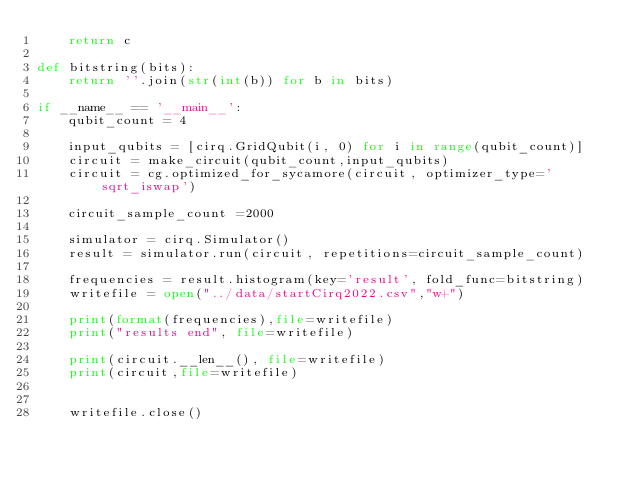Convert code to text. <code><loc_0><loc_0><loc_500><loc_500><_Python_>    return c

def bitstring(bits):
    return ''.join(str(int(b)) for b in bits)

if __name__ == '__main__':
    qubit_count = 4

    input_qubits = [cirq.GridQubit(i, 0) for i in range(qubit_count)]
    circuit = make_circuit(qubit_count,input_qubits)
    circuit = cg.optimized_for_sycamore(circuit, optimizer_type='sqrt_iswap')

    circuit_sample_count =2000

    simulator = cirq.Simulator()
    result = simulator.run(circuit, repetitions=circuit_sample_count)

    frequencies = result.histogram(key='result', fold_func=bitstring)
    writefile = open("../data/startCirq2022.csv","w+")

    print(format(frequencies),file=writefile)
    print("results end", file=writefile)

    print(circuit.__len__(), file=writefile)
    print(circuit,file=writefile)


    writefile.close()</code> 